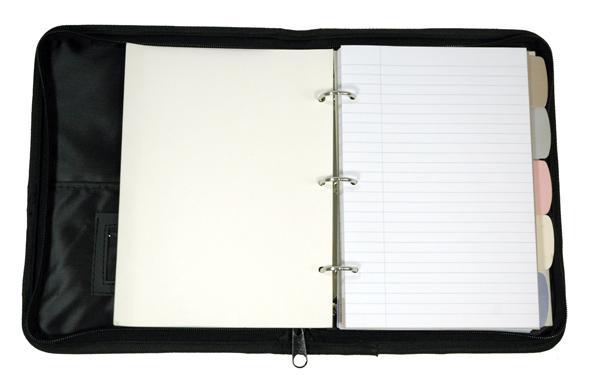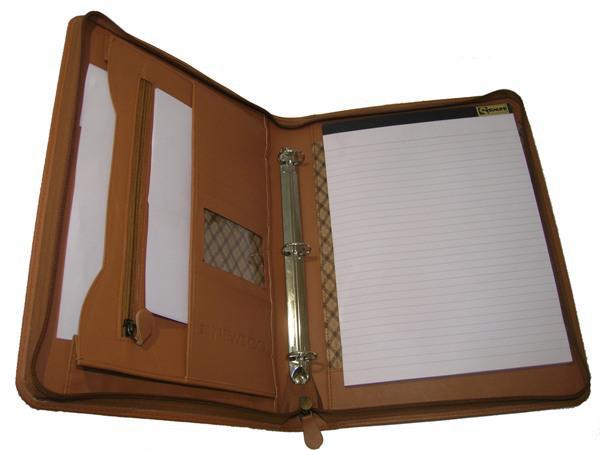The first image is the image on the left, the second image is the image on the right. For the images displayed, is the sentence "there are two open planners in the image pair" factually correct? Answer yes or no. Yes. The first image is the image on the left, the second image is the image on the right. Examine the images to the left and right. Is the description "There is an example of a closed binder." accurate? Answer yes or no. No. 